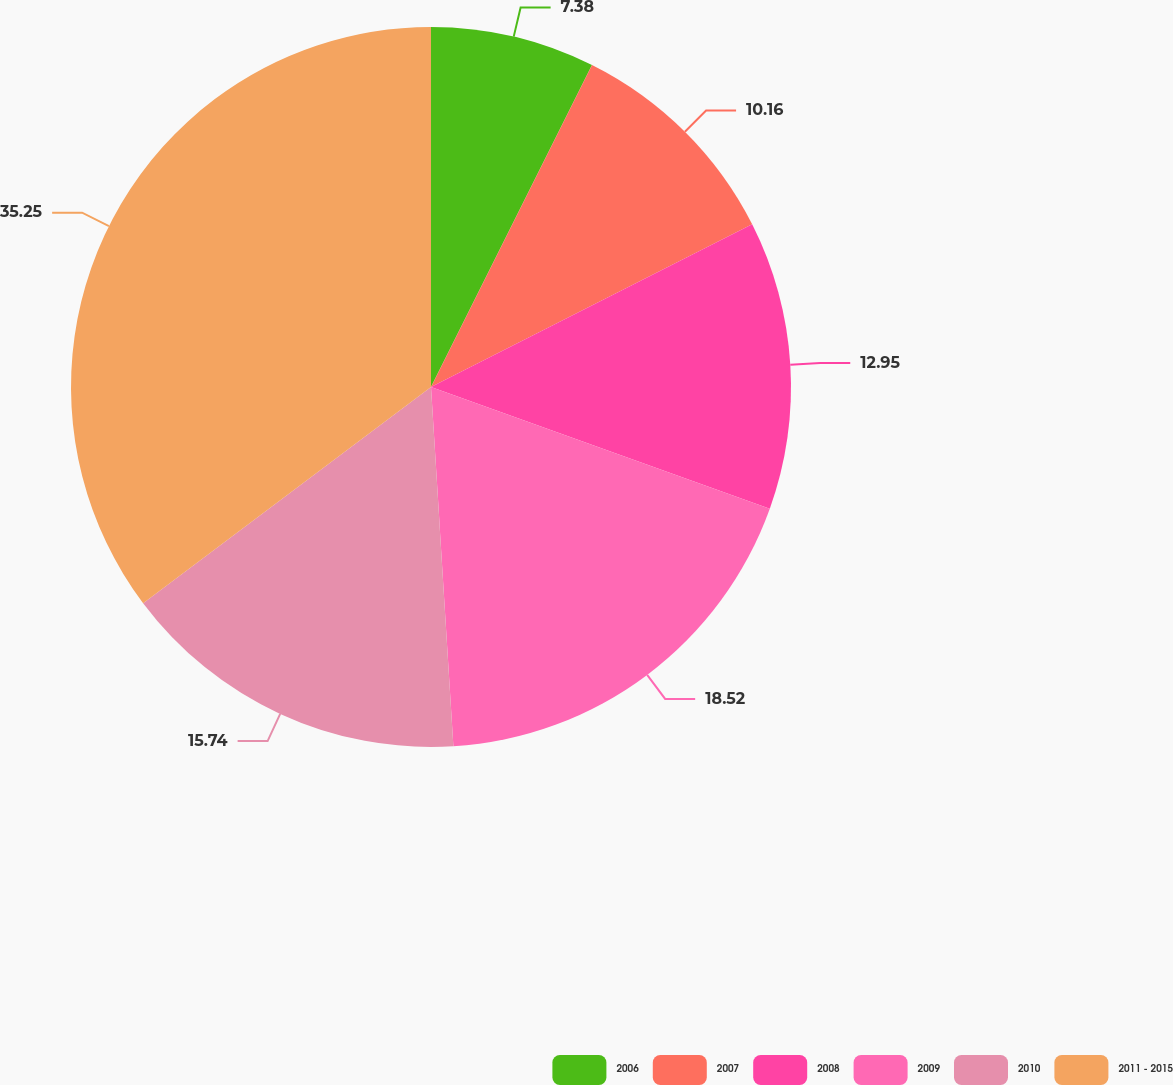Convert chart. <chart><loc_0><loc_0><loc_500><loc_500><pie_chart><fcel>2006<fcel>2007<fcel>2008<fcel>2009<fcel>2010<fcel>2011 - 2015<nl><fcel>7.38%<fcel>10.16%<fcel>12.95%<fcel>18.52%<fcel>15.74%<fcel>35.25%<nl></chart> 